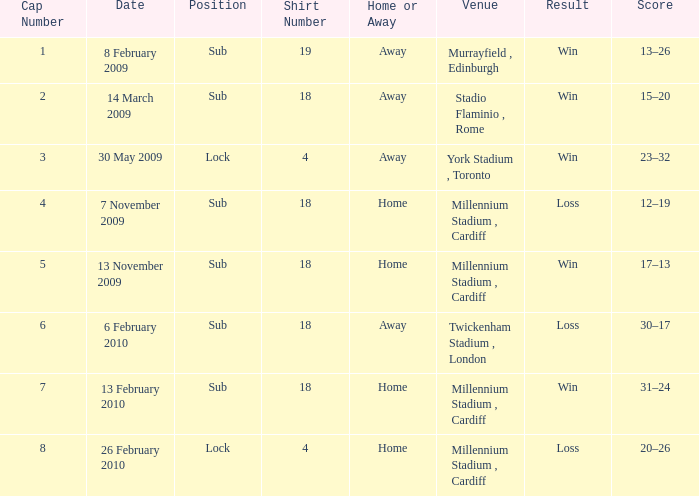Can you tell me the Home or the Away that has the Shirt Number larger than 18? Away. 